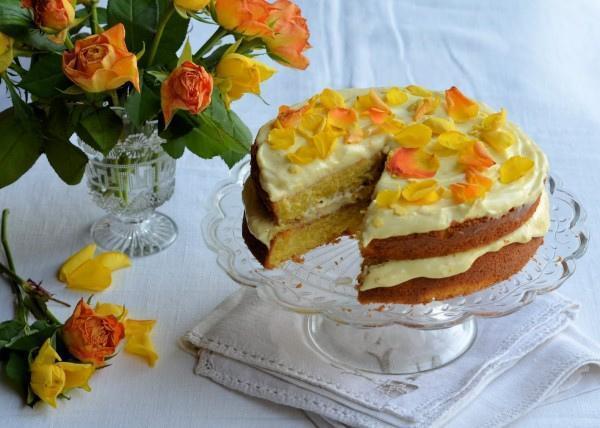Is "The cake is at the right side of the potted plant." an appropriate description for the image?
Answer yes or no. Yes. 